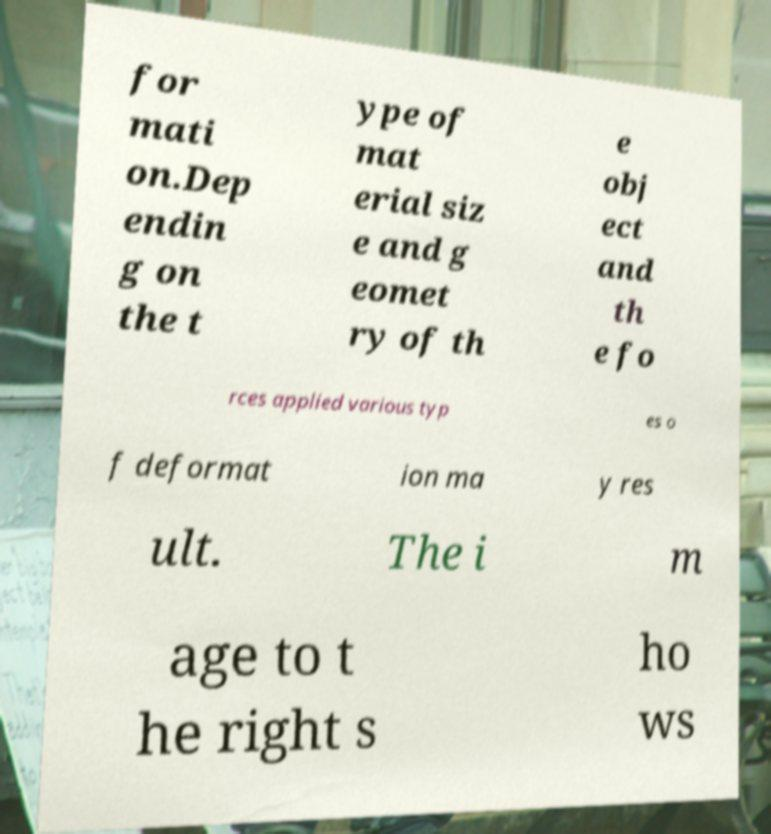Can you read and provide the text displayed in the image?This photo seems to have some interesting text. Can you extract and type it out for me? for mati on.Dep endin g on the t ype of mat erial siz e and g eomet ry of th e obj ect and th e fo rces applied various typ es o f deformat ion ma y res ult. The i m age to t he right s ho ws 